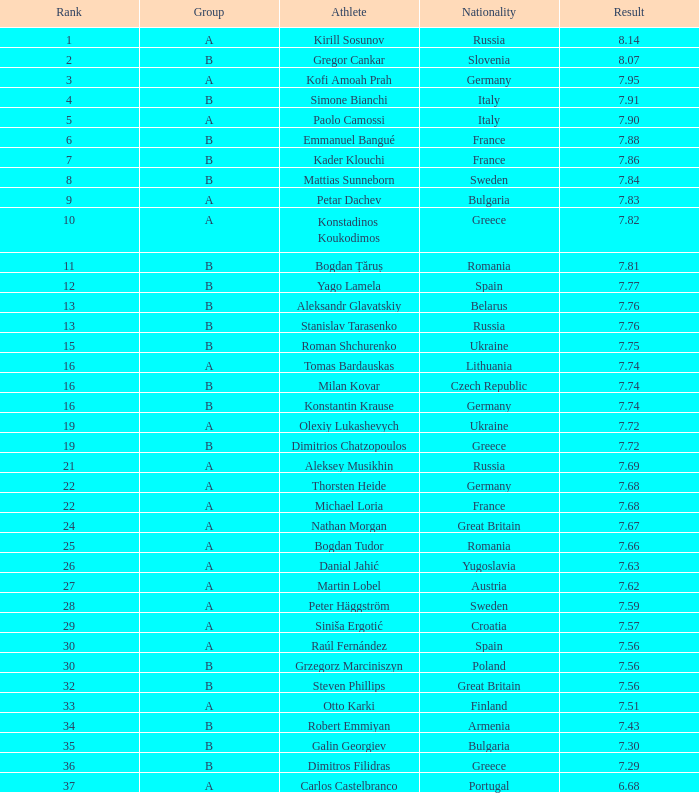In group b, who is the british athlete with a rank higher than 15 and a result below 7.68? Steven Phillips. 